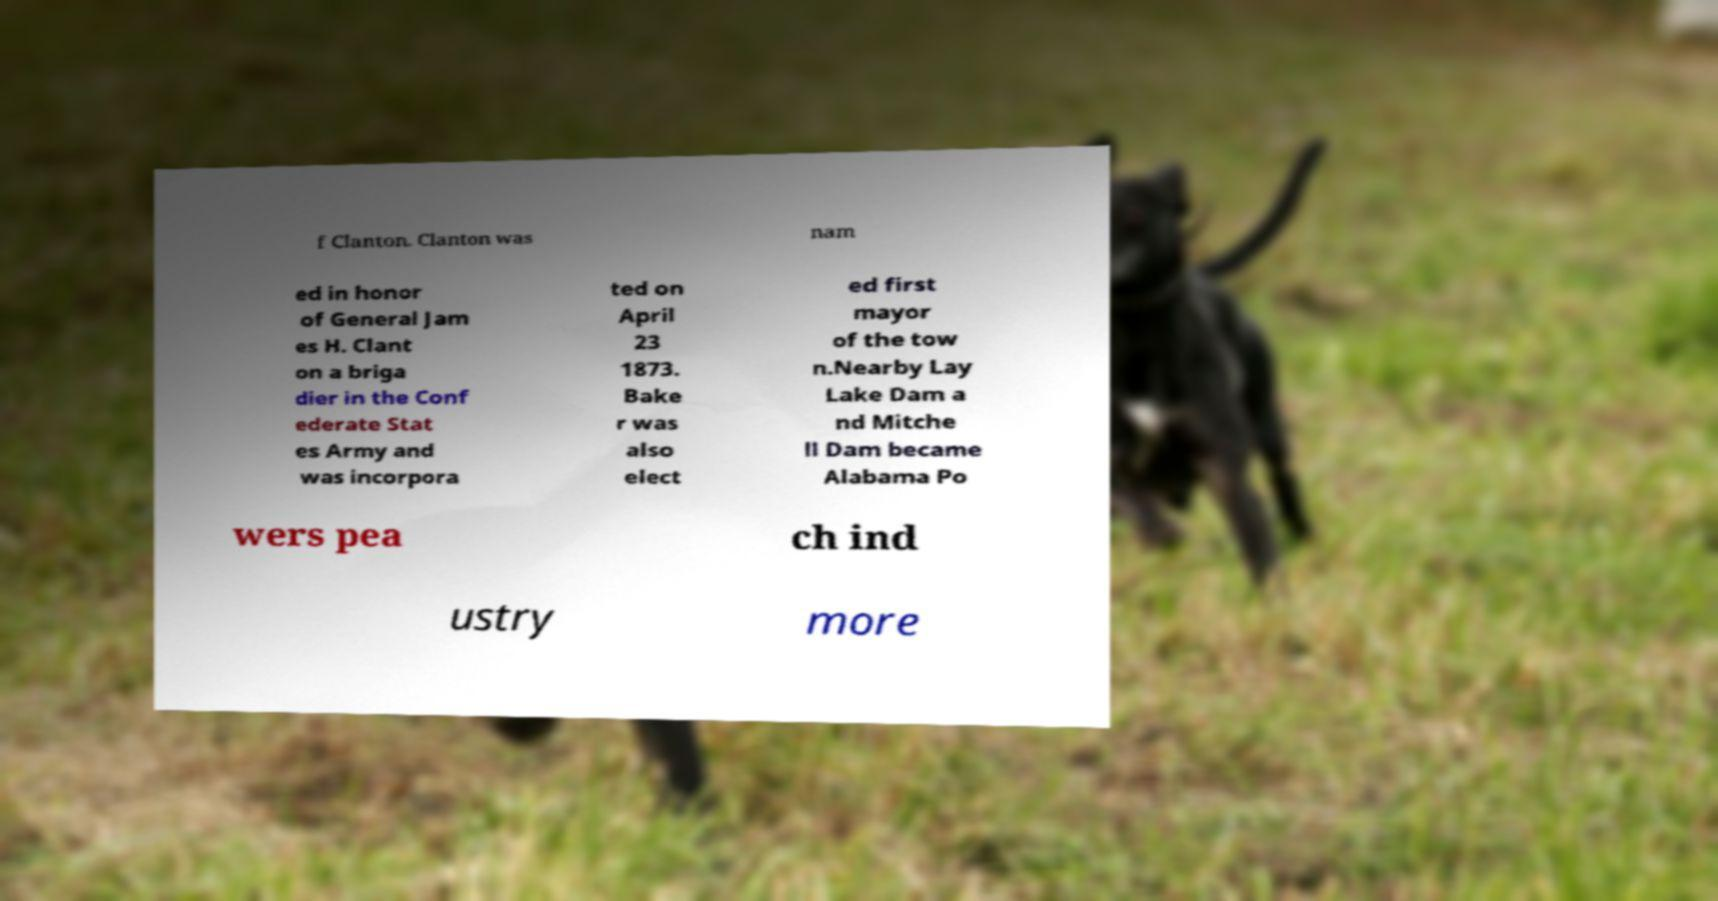I need the written content from this picture converted into text. Can you do that? f Clanton. Clanton was nam ed in honor of General Jam es H. Clant on a briga dier in the Conf ederate Stat es Army and was incorpora ted on April 23 1873. Bake r was also elect ed first mayor of the tow n.Nearby Lay Lake Dam a nd Mitche ll Dam became Alabama Po wers pea ch ind ustry more 